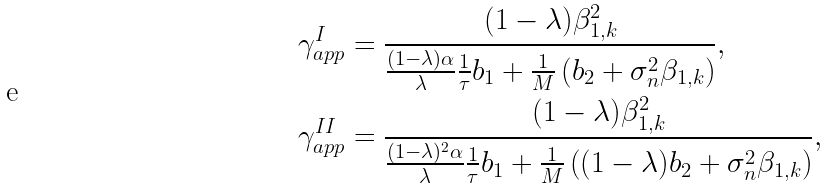Convert formula to latex. <formula><loc_0><loc_0><loc_500><loc_500>\gamma ^ { I } _ { a p p } & = \frac { ( 1 - \lambda ) \beta _ { 1 , k } ^ { 2 } } { \frac { ( 1 - \lambda ) \alpha } { \lambda } \frac { 1 } { \tau } b _ { 1 } + \frac { 1 } { M } \left ( b _ { 2 } + \sigma _ { n } ^ { 2 } \beta _ { 1 , k } \right ) } , \\ \gamma ^ { I I } _ { a p p } & = \frac { ( 1 - \lambda ) \beta _ { 1 , k } ^ { 2 } } { \frac { ( 1 - \lambda ) ^ { 2 } \alpha } { \lambda } \frac { 1 } { \tau } b _ { 1 } + \frac { 1 } { M } \left ( ( 1 - \lambda ) b _ { 2 } + \sigma _ { n } ^ { 2 } \beta _ { 1 , k } \right ) } ,</formula> 